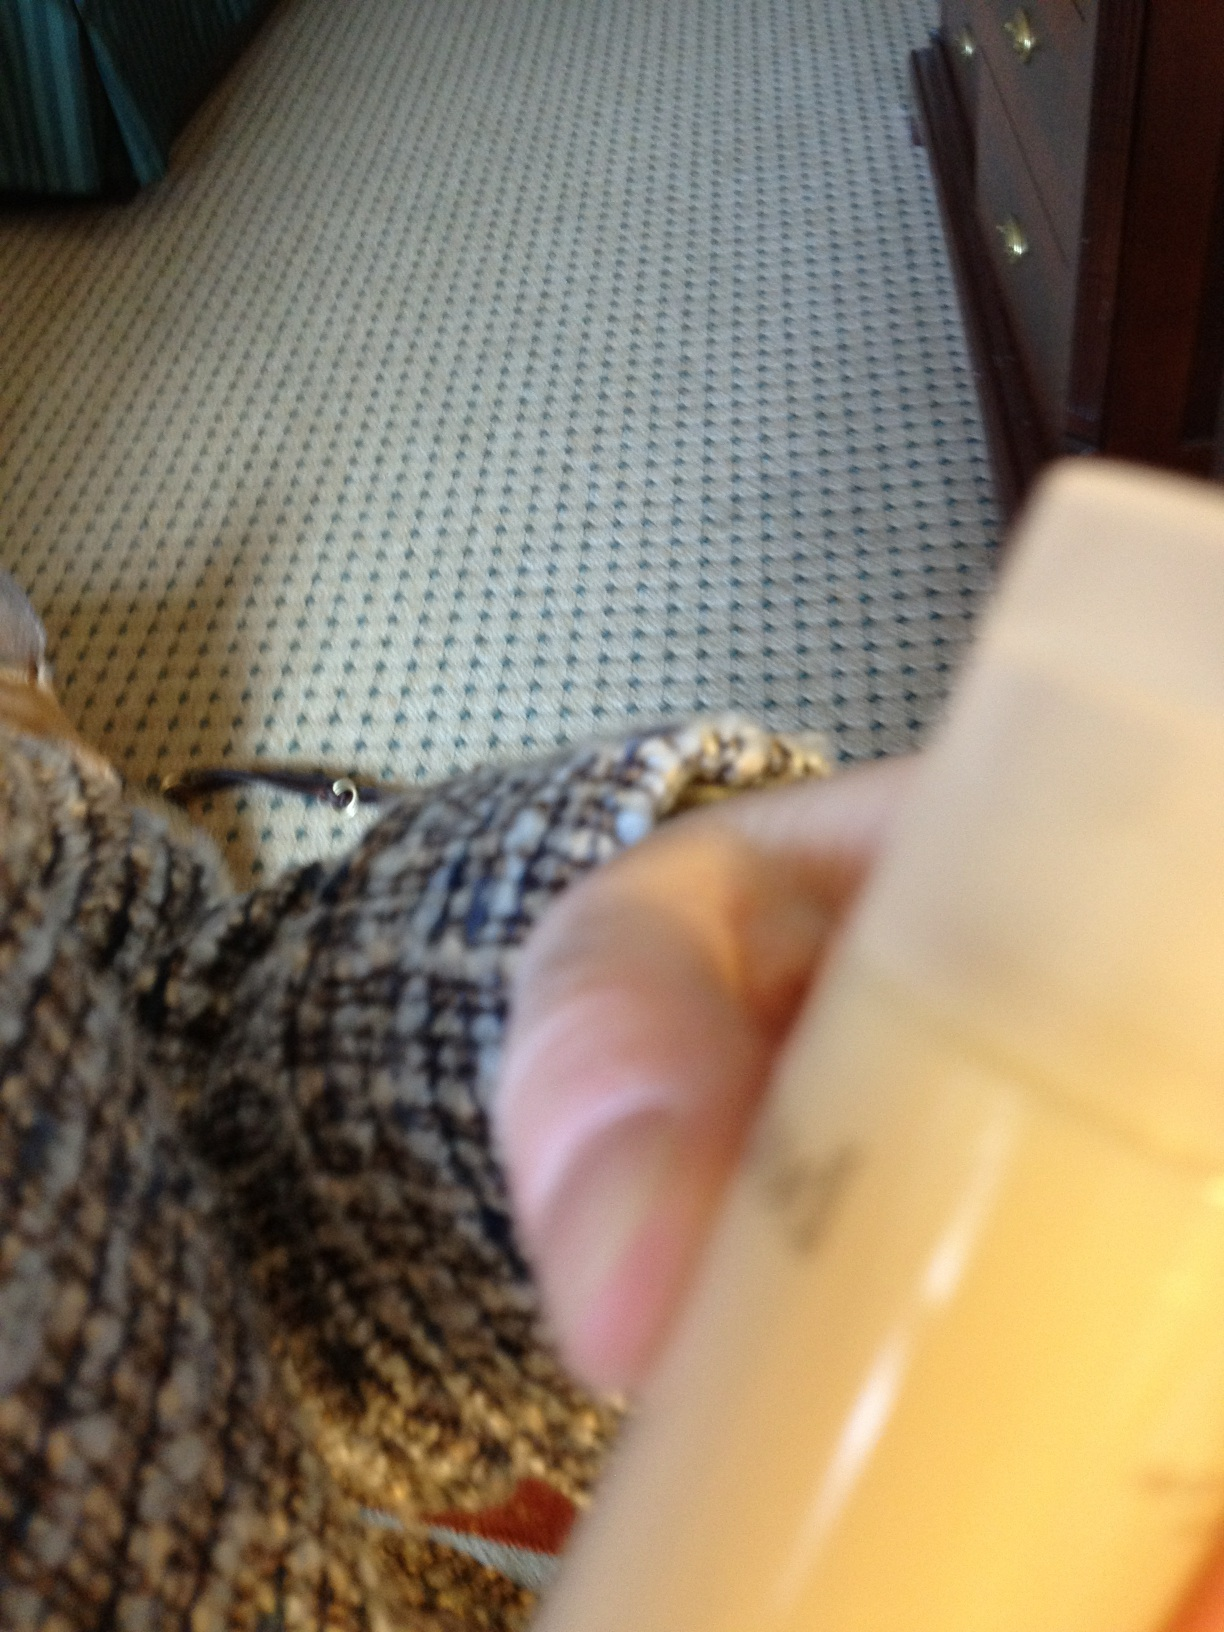What type of personal care product do you think this is, considering the shape and style of the container? Given the opaque bottle and rather thick form, it might be a lotion or a cream used for skincare, often designed for convenient use with this type of dispenser. 